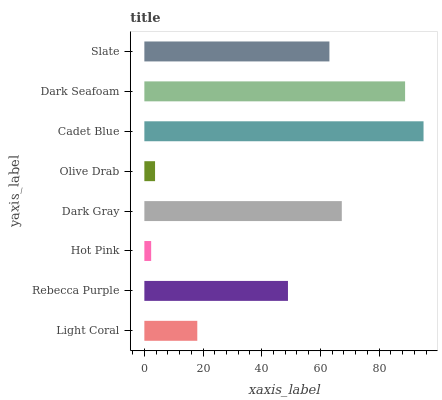Is Hot Pink the minimum?
Answer yes or no. Yes. Is Cadet Blue the maximum?
Answer yes or no. Yes. Is Rebecca Purple the minimum?
Answer yes or no. No. Is Rebecca Purple the maximum?
Answer yes or no. No. Is Rebecca Purple greater than Light Coral?
Answer yes or no. Yes. Is Light Coral less than Rebecca Purple?
Answer yes or no. Yes. Is Light Coral greater than Rebecca Purple?
Answer yes or no. No. Is Rebecca Purple less than Light Coral?
Answer yes or no. No. Is Slate the high median?
Answer yes or no. Yes. Is Rebecca Purple the low median?
Answer yes or no. Yes. Is Rebecca Purple the high median?
Answer yes or no. No. Is Cadet Blue the low median?
Answer yes or no. No. 